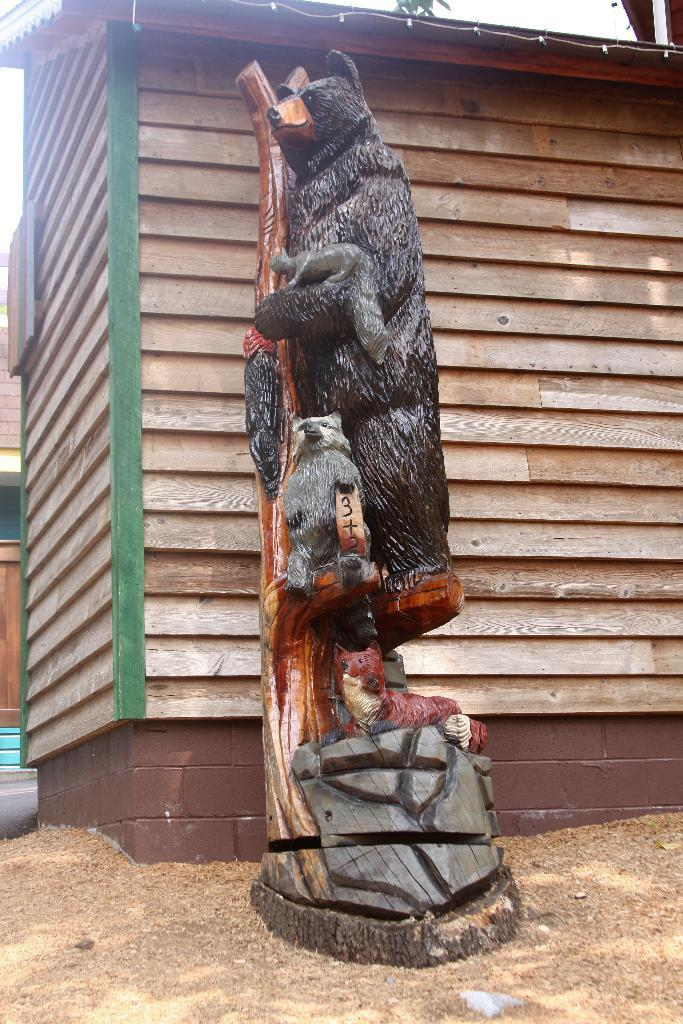What is there are toys in the center of the image, what are they? There are toys in the center of the image, but the specific types of toys are not mentioned in the facts. What can be seen in the background of the image? There are houses in the background of the image. What is visible at the bottom of the image? There is sand visible at the bottom of the image. Reasoning: Let' Let's think step by step in order to produce the conversation. We start by identifying the main subject in the image, which is the toys. Then, we expand the conversation to include other elements of the image, such as the houses in the background and the sand at the bottom. Each question is designed to elicit a specific detail about the image that is known from the provided facts. Absurd Question/Answer: How many glasses of water are present in the image? There is no mention of glasses or water in the provided facts, so it cannot be determined from the image. How many cows are grazing in the image? There is no mention of cows or grazing in the provided facts, so it cannot be determined from the image. --- Facts: 1. There is a person sitting on a chair in the image. 2. The person is holding a book. 3. There is a table next to the chair. 4. There is a lamp on the table. Absurd Topics: parrot, ocean, dance Conversation: What is the person in the image doing? The person in the image is sitting on a chair. What is the person holding in the image? The person is holding a book. What is located next to the chair in the image? There is a table next to the chair. What is on the table in the image? There is a lamp on the table. Reasoning: Let's think step by step in order to produce the conversation. We start by identifying the main subject in the image, which is the person sitting on a chair. Then, we expand the conversation to include other elements of the image, such as the book, table, and lamp. Each question is designed to elicit a specific detail about the image that is known from the provided facts. Absurd Question/Answer: 